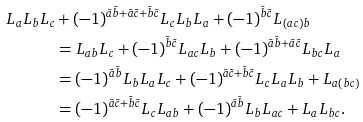<formula> <loc_0><loc_0><loc_500><loc_500>L _ { a } L _ { b } L _ { c } & + ( - 1 ) ^ { \bar { a } \bar { b } + \bar { a } \bar { c } + \bar { b } \bar { c } } L _ { c } L _ { b } L _ { a } + ( - 1 ) ^ { \bar { b } \bar { c } } L _ { ( a c ) b } \\ & = L _ { a b } L _ { c } + ( - 1 ) ^ { \bar { b } \bar { c } } L _ { a c } L _ { b } + ( - 1 ) ^ { \bar { a } \bar { b } + \bar { a } \bar { c } } L _ { b c } L _ { a } \\ & = ( - 1 ) ^ { \bar { a } \bar { b } } L _ { b } L _ { a } L _ { c } + ( - 1 ) ^ { \bar { a } \bar { c } + \bar { b } \bar { c } } L _ { c } L _ { a } L _ { b } + L _ { a ( b c ) } \\ & = ( - 1 ) ^ { \bar { a } \bar { c } + \bar { b } \bar { c } } L _ { c } L _ { a b } + ( - 1 ) ^ { \bar { a } \bar { b } } L _ { b } L _ { a c } + L _ { a } L _ { b c } .</formula> 